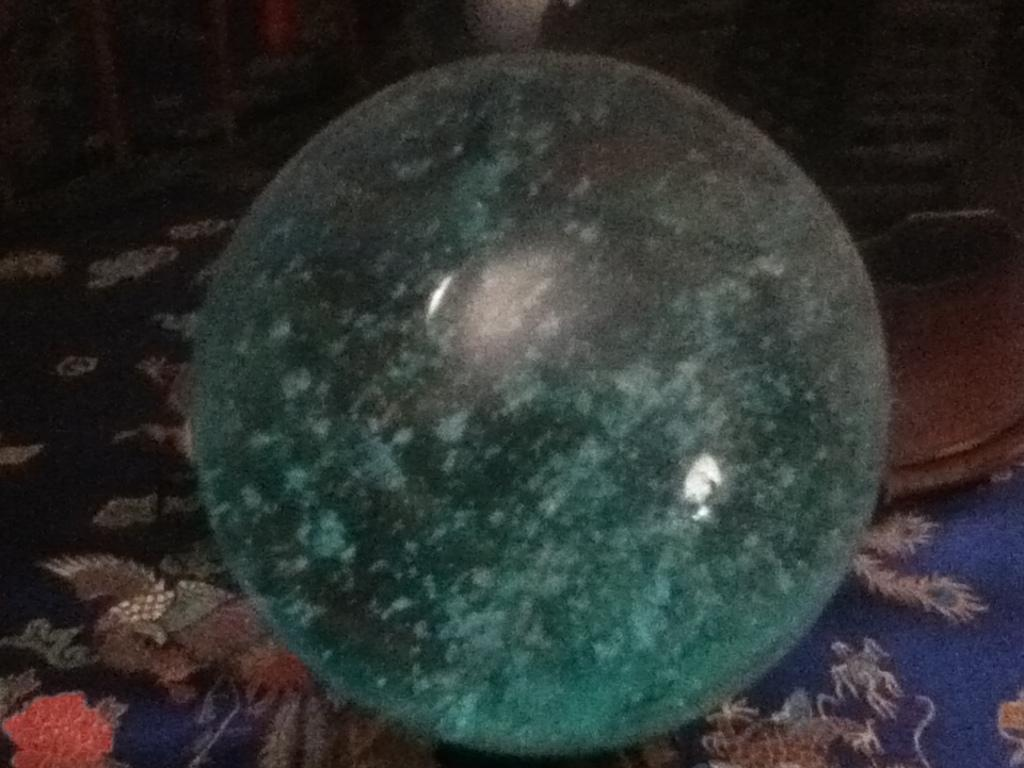What is the main subject in the image? There is an object in the image. Can you describe the cloth at the bottom of the image? Yes, there is a cloth at the bottom of the image. What type of whistle can be heard in the image? There is no whistle present in the image, and therefore no sound can be heard. What does the image smell like? Images do not have a smell, as they are visual representations. 